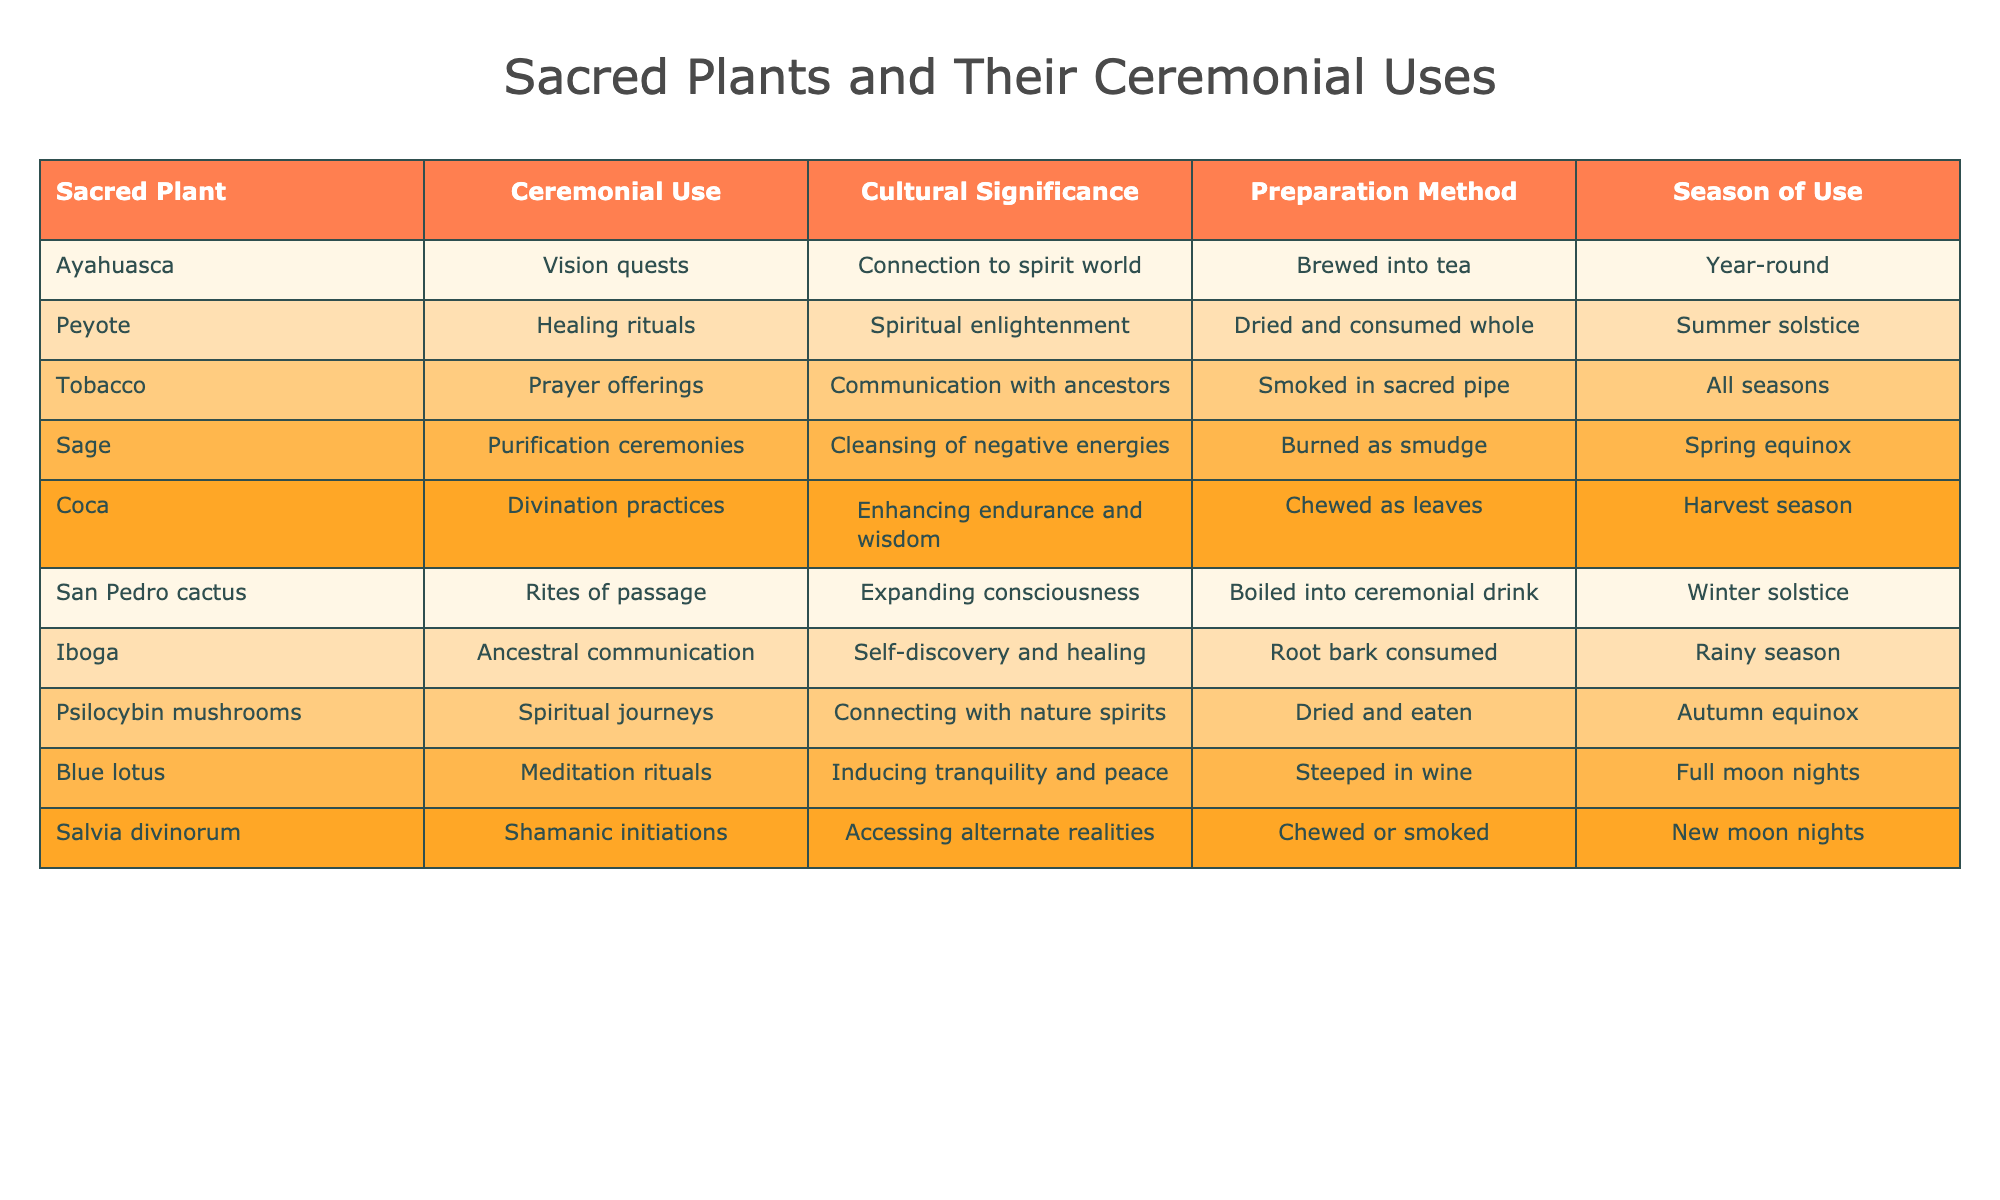What is the ceremonial use of Ayahuasca? In the table, the row for Ayahuasca lists its ceremonial use as "Vision quests."
Answer: Vision quests Which sacred plant is associated with communication with ancestors? The table shows that Tobacco is linked to "Communication with ancestors."
Answer: Tobacco How many sacred plants are used in winter solstice ceremonies? The table indicates that two plants, San Pedro cactus and Salvia divinorum, are used in winter solstice ceremonies.
Answer: 2 Which plant is used in purification ceremonies, and what is its preparation method? According to the table, Sage is used in purification ceremonies, and it is prepared by being "Burned as smudge."
Answer: Sage; Burned as smudge Does Iboga have a ceremonial use related to healing? The table notes that Iboga is used for "Self-discovery and healing," so it is associated with healing.
Answer: Yes How many plants are prepared by being chewed, and what are their names? The table lists Coca and Salvia divinorum as the plants prepared by being chewed, totaling two.
Answer: 2; Coca, Salvia divinorum What is the cultural significance of Peyote? The table indicates that the cultural significance of Peyote is "Spiritual enlightenment."
Answer: Spiritual enlightenment During which season is Sage primarily used? The table specifies that Sage is used during the "Spring equinox."
Answer: Spring equinox Which plant has the preparation method of being "Steeped in wine"? In the table, Blue lotus is associated with being "Steeped in wine."
Answer: Blue lotus If you were to compare the ceremonial uses of plants used for purification and communication with ancestors, how do they differ? The table indicates that Sage is for "Purification ceremonies," while Tobacco is for "Communication with ancestors," showing a distinction between cleansing and ancestral connection.
Answer: They differ in purpose; purification vs. ancestral connection Are there any sacred plants that are used year-round? Yes, the table indicates that Ayahuasca and Tobacco can be used year-round.
Answer: Yes 